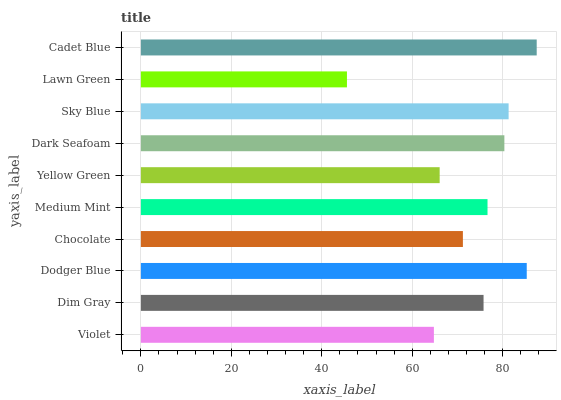Is Lawn Green the minimum?
Answer yes or no. Yes. Is Cadet Blue the maximum?
Answer yes or no. Yes. Is Dim Gray the minimum?
Answer yes or no. No. Is Dim Gray the maximum?
Answer yes or no. No. Is Dim Gray greater than Violet?
Answer yes or no. Yes. Is Violet less than Dim Gray?
Answer yes or no. Yes. Is Violet greater than Dim Gray?
Answer yes or no. No. Is Dim Gray less than Violet?
Answer yes or no. No. Is Medium Mint the high median?
Answer yes or no. Yes. Is Dim Gray the low median?
Answer yes or no. Yes. Is Dodger Blue the high median?
Answer yes or no. No. Is Dark Seafoam the low median?
Answer yes or no. No. 